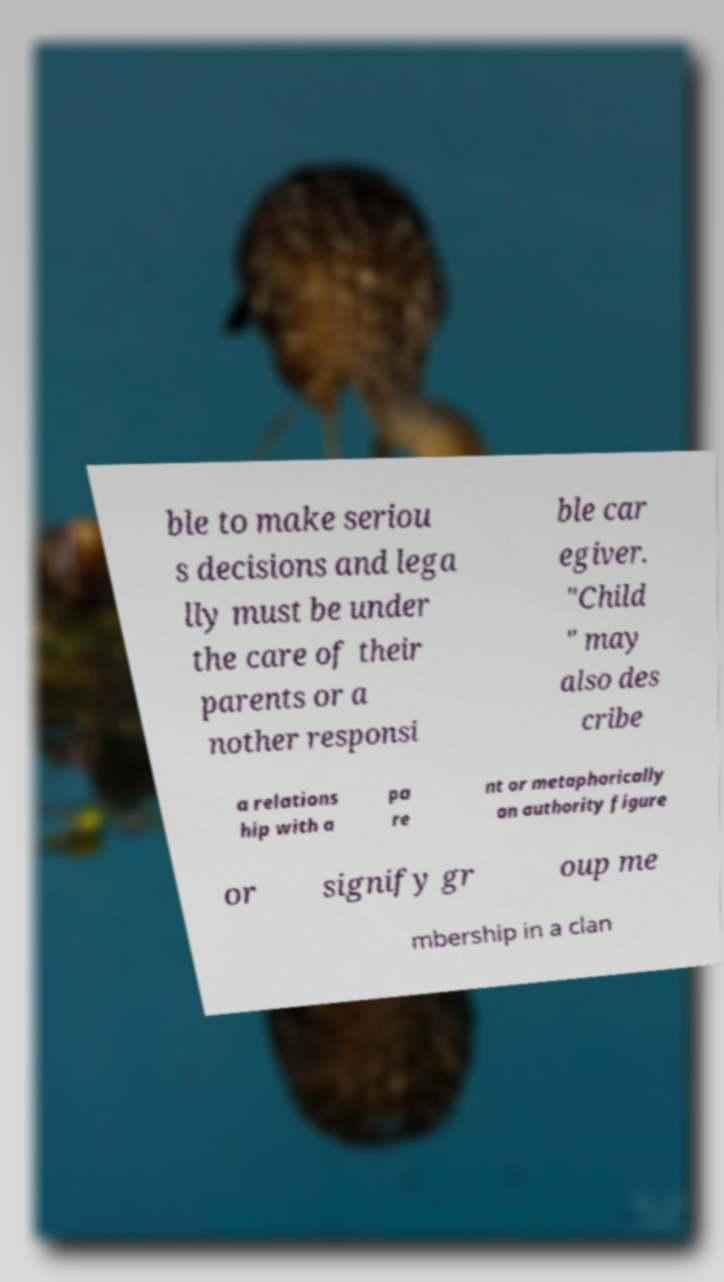Can you accurately transcribe the text from the provided image for me? ble to make seriou s decisions and lega lly must be under the care of their parents or a nother responsi ble car egiver. "Child " may also des cribe a relations hip with a pa re nt or metaphorically an authority figure or signify gr oup me mbership in a clan 